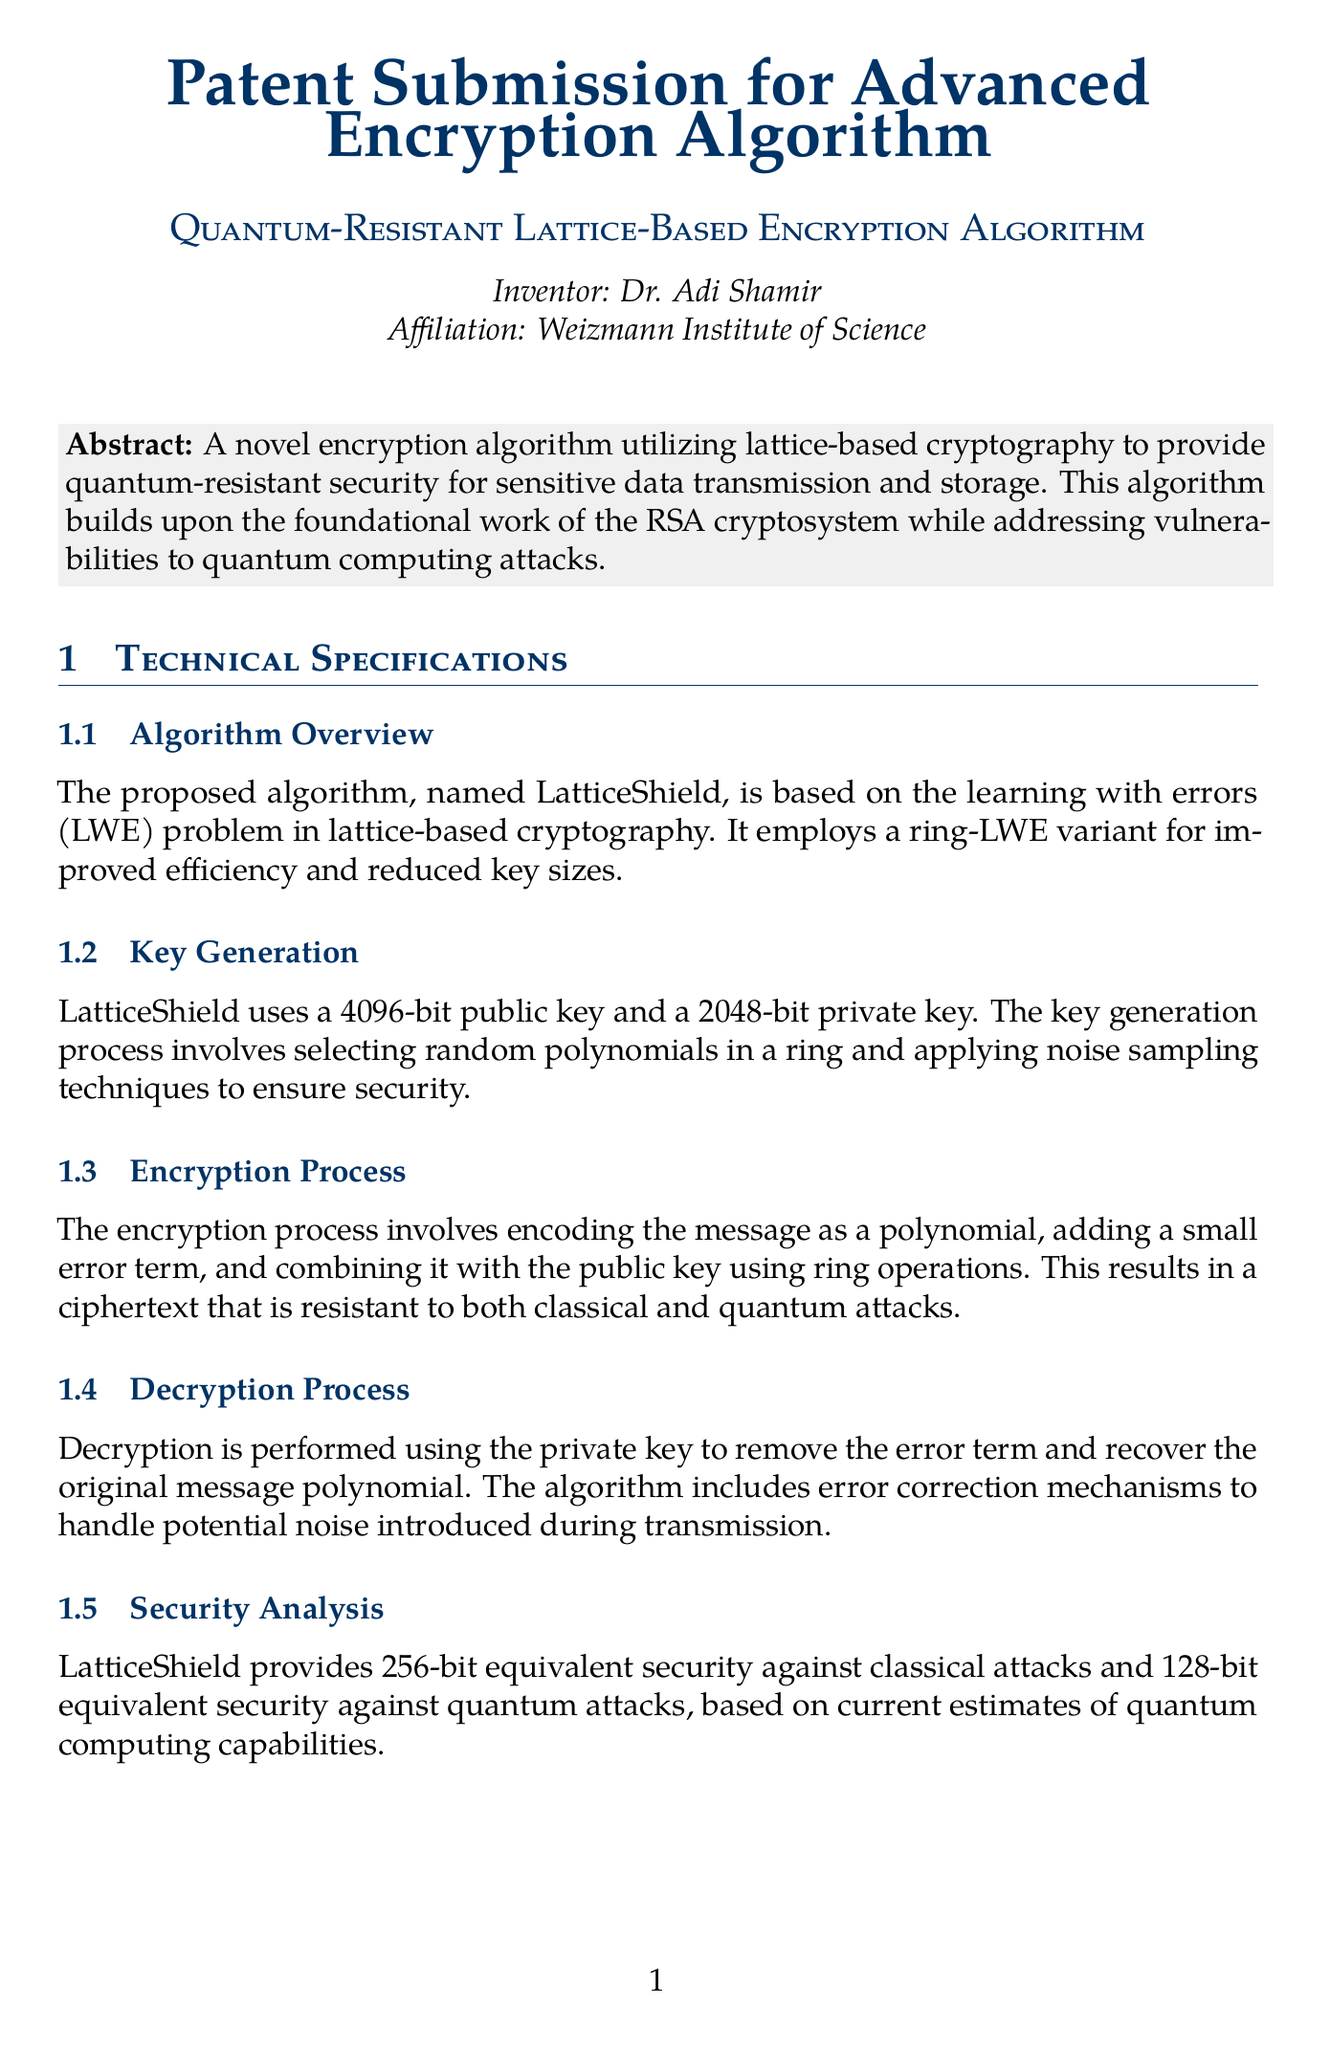What is the title of the invention? The title of the invention is provided in the document under "inventionTitle."
Answer: Quantum-Resistant Lattice-Based Encryption Algorithm Who is the inventor of the algorithm? The inventor's name is listed prominently in the document under "inventorName."
Answer: Dr. Adi Shamir What is the public key size used in the key generation process? The document specifies the size of the public key in the "Key Generation" section.
Answer: 4096-bit What is the security equivalence against quantum attacks? The "Security Analysis" section of the document provides the security equivalence against quantum attacks.
Answer: 128-bit Which cryptographic problem is the algorithm based on? The algorithm overview indicates the foundational problem on which the proposed algorithm is based.
Answer: learning with errors What application is mentioned for the encryption algorithm? The document lists potential applications that utilize the proposed algorithm.
Answer: Secure communication channels for government and military use What type of cryptography does LatticeShield utilize? The abstract description refers to the type of cryptography utilized by the algorithm.
Answer: lattice-based cryptography What are the advantages of LatticeShield over RSA? The "Comparisons" section lists advantages specifically over RSA.
Answer: Quantum-resistant, Faster key generation, Smaller key sizes for equivalent security levels What is the affiliation of the inventor? The inventor's affiliation is mentioned directly under their name.
Answer: Weizmann Institute of Science 